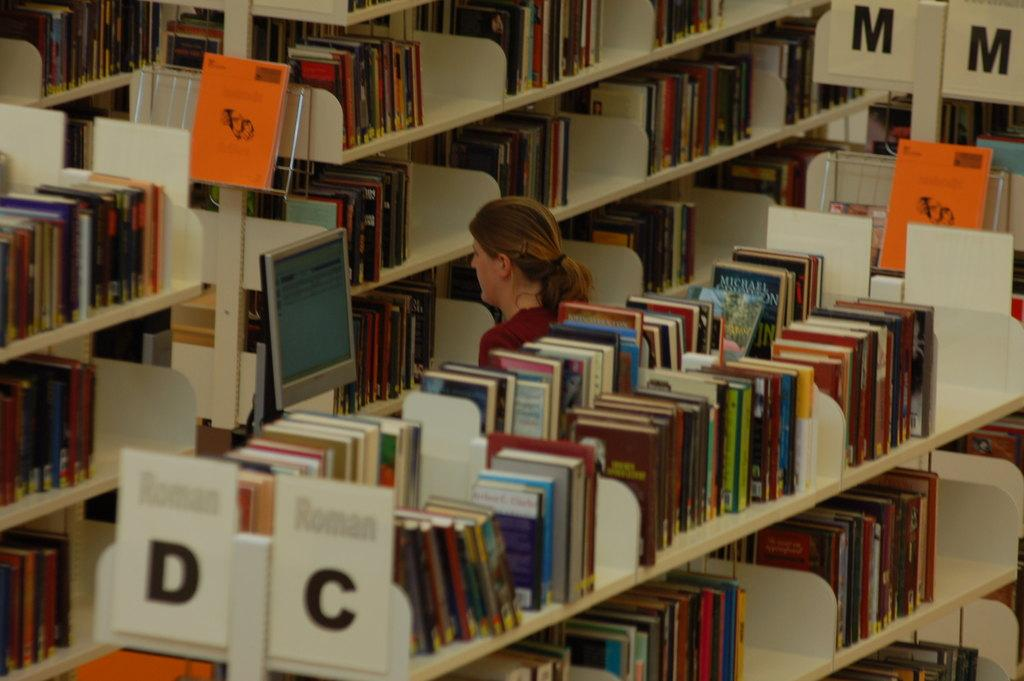<image>
Present a compact description of the photo's key features. Woman standing in a library near section D and C. 